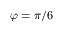Convert formula to latex. <formula><loc_0><loc_0><loc_500><loc_500>\varphi = \pi / 6</formula> 